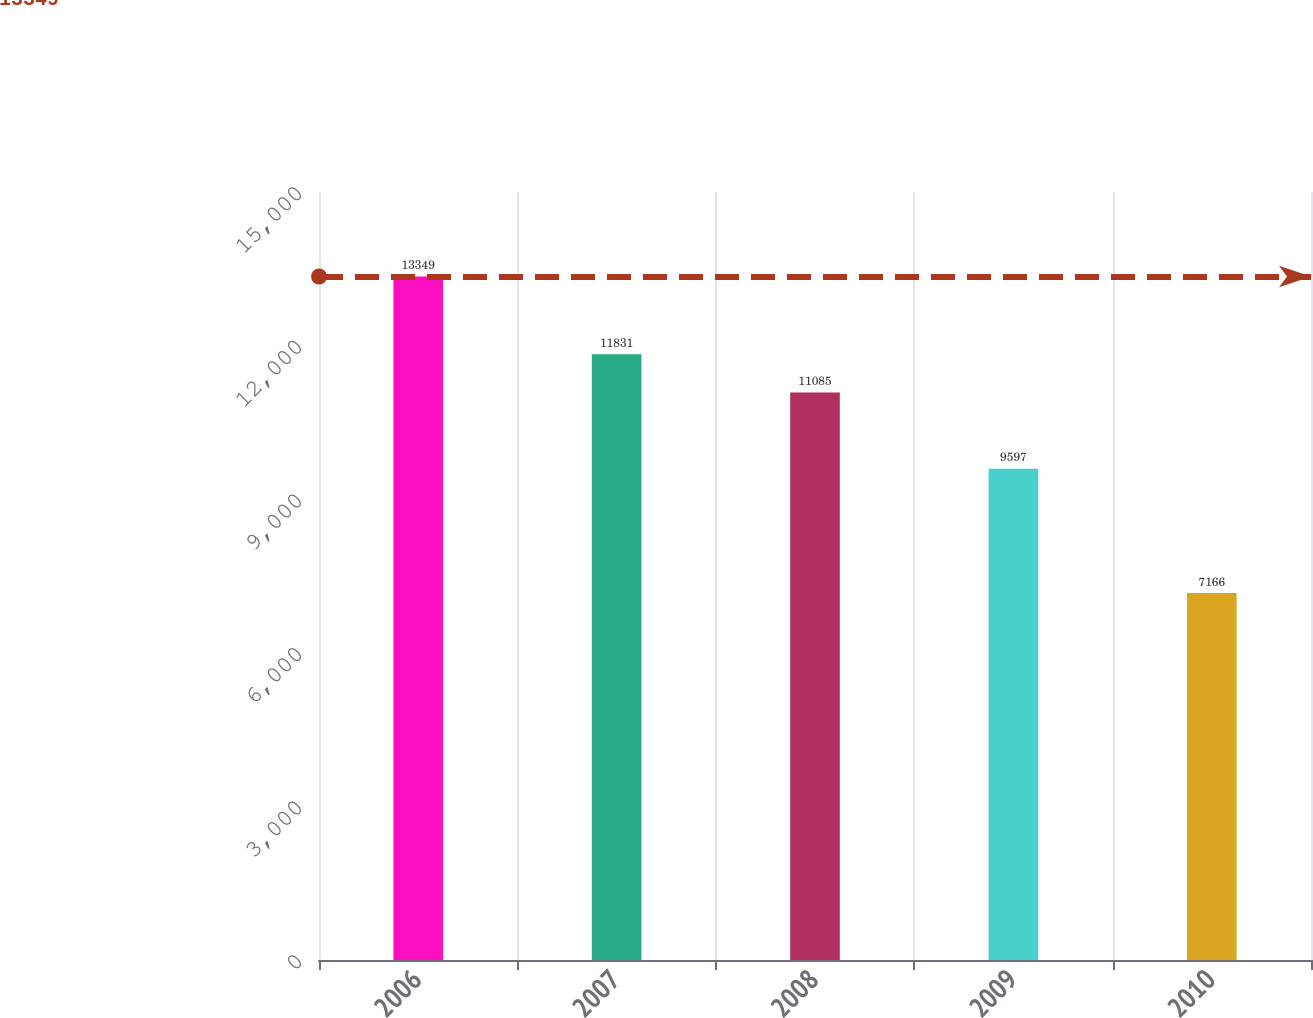<chart> <loc_0><loc_0><loc_500><loc_500><bar_chart><fcel>2006<fcel>2007<fcel>2008<fcel>2009<fcel>2010<nl><fcel>13349<fcel>11831<fcel>11085<fcel>9597<fcel>7166<nl></chart> 